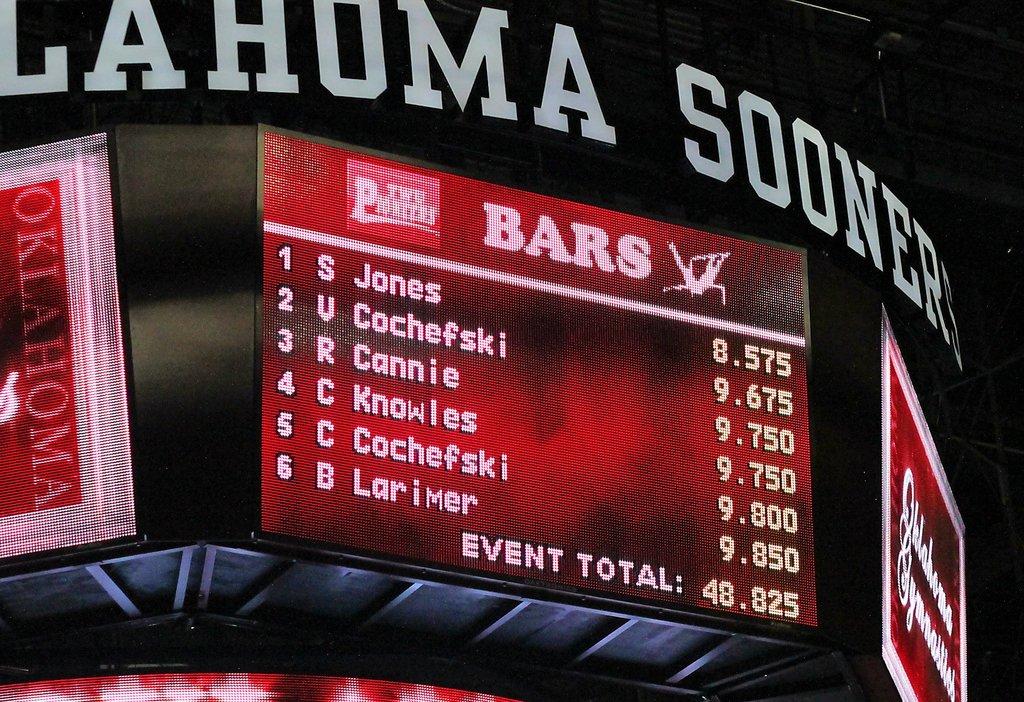Who are the top six players?
Make the answer very short. S jones, v cochefski, r cannie, c knowles, c cochefski, b larimer. What's the highest total in this?
Give a very brief answer. 9.850. 